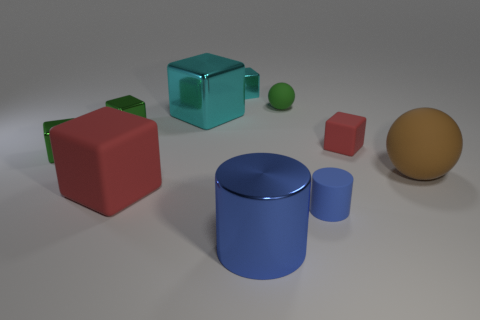Subtract all cyan cubes. How many cubes are left? 4 Subtract all green metal cubes. How many cubes are left? 4 Subtract all purple cubes. Subtract all purple balls. How many cubes are left? 6 Subtract all spheres. How many objects are left? 8 Add 1 rubber cylinders. How many rubber cylinders exist? 2 Subtract 2 green cubes. How many objects are left? 8 Subtract all tiny blue matte cylinders. Subtract all green objects. How many objects are left? 6 Add 6 tiny cubes. How many tiny cubes are left? 10 